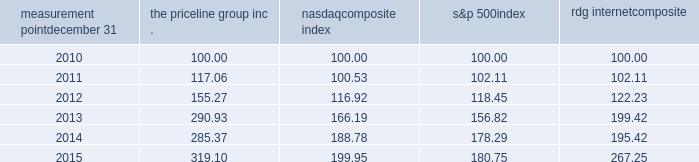Measurement point december 31 the priceline group nasdaq composite index s&p 500 rdg internet composite .

What was the percent of the growth of the the priceline group inc . from 2014 to 2015? 
Rationale: the percent of the growth of the the priceline group inc . from 2014 to 2015 was 11.8%
Computations: ((319.10 - 285.37) / 285.37)
Answer: 0.1182. 